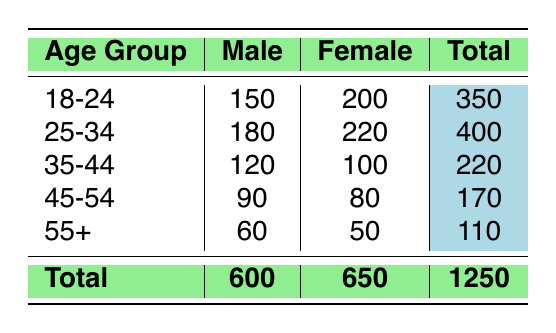What is the total participation of males in ocean clean-up initiatives? The total participation of males can be found by adding the male participation across all age groups: 150 (18-24) + 180 (25-34) + 120 (35-44) + 90 (45-54) + 60 (55+) = 600.
Answer: 600 What is the total participation of females in ocean clean-up initiatives? Similar to the male participation, we sum the female participation across all age groups: 200 (18-24) + 220 (25-34) + 100 (35-44) + 80 (45-54) + 50 (55+) = 650.
Answer: 650 Which age group has the highest male participation? To determine the highest male participation, compare the male participation numbers for each age group. The numbers are: 150, 180, 120, 90, and 60. The highest value is 180 from the 25-34 age group.
Answer: 25-34 Which age group has the lowest female participation? To find the lowest female participation, compare the female participation numbers: 200, 220, 100, 80, and 50. The lowest value is 50 from the 55+ age group.
Answer: 55+ Is the total male participation greater than the total female participation? To answer, compare the two totals calculated earlier: total male participation is 600 and total female participation is 650. Since 600 is less than 650, the statement is false.
Answer: No What is the average female participation per age group? There are 5 age groups, and the total female participation is 650. To find the average, divide the total by the number of age groups: 650/5 = 130.
Answer: 130 If we combine the participation of the age groups 35-44, 45-54, and 55+, what is the total participation? First, we sum the total participation for each of these age groups: 220 (35-44) + 170 (45-54) + 110 (55+) = 500.
Answer: 500 What percentage of the total participation is made up by females? The total participation is 1250, and total female participation is 650. To find the percentage, use the formula (female participation/total participation) × 100: (650/1250) × 100 = 52%.
Answer: 52% What is the difference in participation between the highest and lowest age group's female participation? The highest female participation is 220 (25-34) and the lowest is 50 (55+). Calculate the difference: 220 - 50 = 170.
Answer: 170 